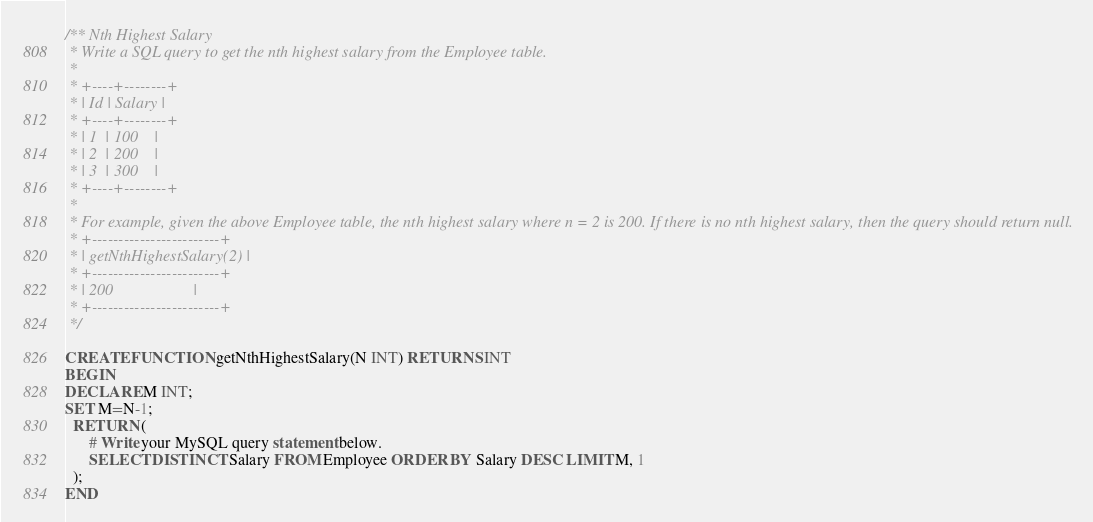<code> <loc_0><loc_0><loc_500><loc_500><_SQL_>/** Nth Highest Salary
 * Write a SQL query to get the nth highest salary from the Employee table.
 *
 * +----+--------+
 * | Id | Salary |
 * +----+--------+
 * | 1  | 100    |
 * | 2  | 200    |
 * | 3  | 300    |
 * +----+--------+
 *
 * For example, given the above Employee table, the nth highest salary where n = 2 is 200. If there is no nth highest salary, then the query should return null.
 * +------------------------+
 * | getNthHighestSalary(2) |
 * +------------------------+
 * | 200                    |
 * +------------------------+
 */

CREATE FUNCTION getNthHighestSalary(N INT) RETURNS INT
BEGIN
DECLARE M INT;
SET M=N-1;
  RETURN (
      # Write your MySQL query statement below.
      SELECT DISTINCT Salary FROM Employee ORDER BY Salary DESC LIMIT M, 1
  );
END</code> 